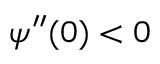Convert formula to latex. <formula><loc_0><loc_0><loc_500><loc_500>\psi ^ { \prime \prime } ( 0 ) < 0</formula> 